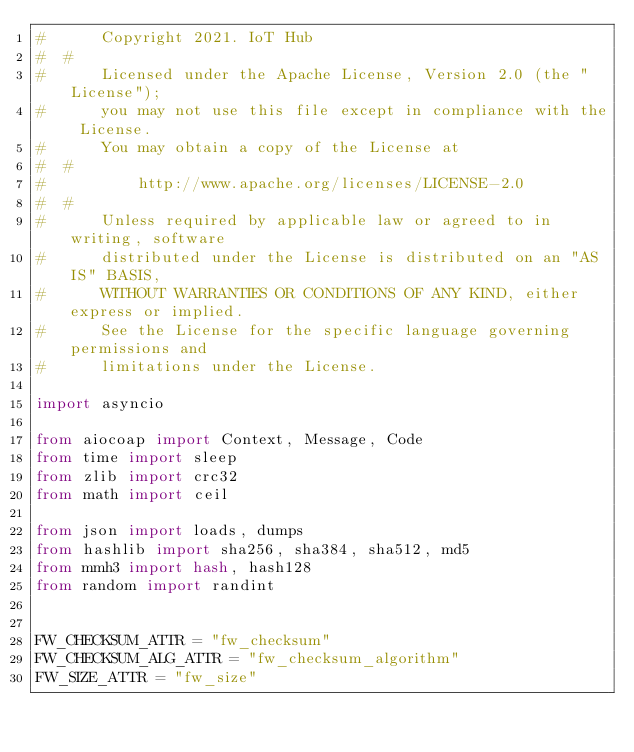<code> <loc_0><loc_0><loc_500><loc_500><_Python_>#      Copyright 2021. IoT Hub
#  #
#      Licensed under the Apache License, Version 2.0 (the "License");
#      you may not use this file except in compliance with the License.
#      You may obtain a copy of the License at
#  #
#          http://www.apache.org/licenses/LICENSE-2.0
#  #
#      Unless required by applicable law or agreed to in writing, software
#      distributed under the License is distributed on an "AS IS" BASIS,
#      WITHOUT WARRANTIES OR CONDITIONS OF ANY KIND, either express or implied.
#      See the License for the specific language governing permissions and
#      limitations under the License.

import asyncio

from aiocoap import Context, Message, Code
from time import sleep
from zlib import crc32
from math import ceil

from json import loads, dumps
from hashlib import sha256, sha384, sha512, md5
from mmh3 import hash, hash128
from random import randint


FW_CHECKSUM_ATTR = "fw_checksum"
FW_CHECKSUM_ALG_ATTR = "fw_checksum_algorithm"
FW_SIZE_ATTR = "fw_size"</code> 